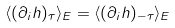Convert formula to latex. <formula><loc_0><loc_0><loc_500><loc_500>\langle ( \partial _ { i } h ) _ { \tau } \rangle _ { E } = \langle ( \partial _ { i } h ) _ { - \tau } \rangle _ { E }</formula> 